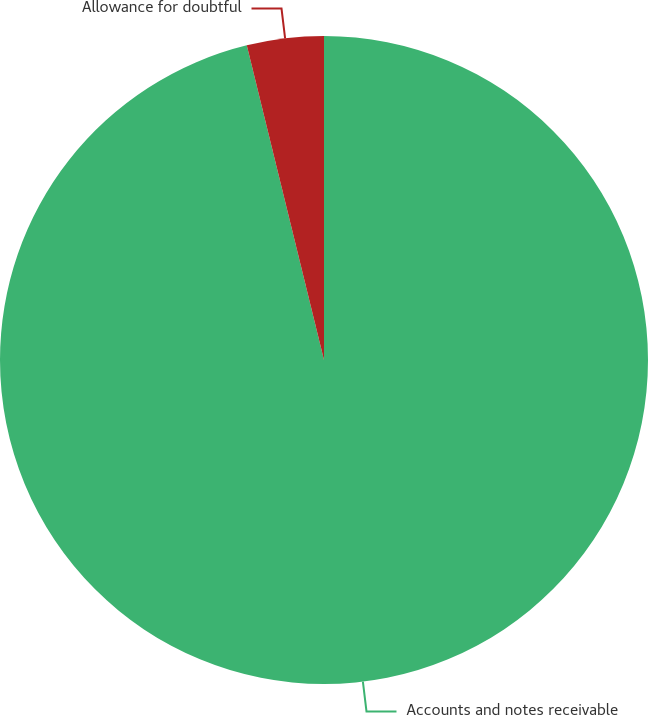<chart> <loc_0><loc_0><loc_500><loc_500><pie_chart><fcel>Accounts and notes receivable<fcel>Allowance for doubtful<nl><fcel>96.17%<fcel>3.83%<nl></chart> 